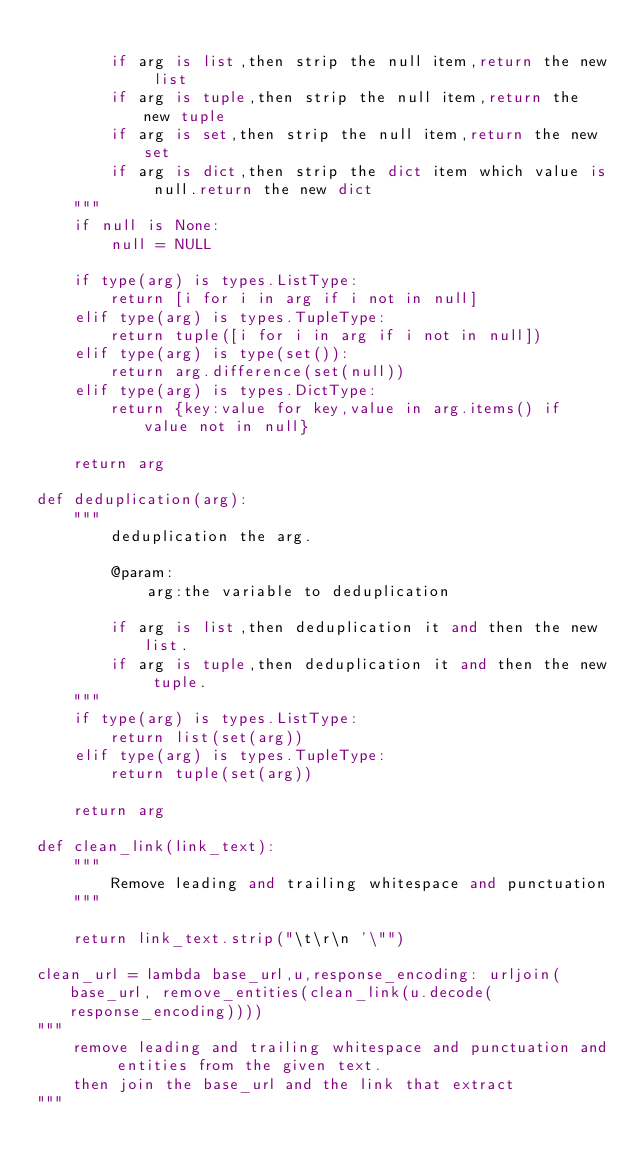<code> <loc_0><loc_0><loc_500><loc_500><_Python_>
        if arg is list,then strip the null item,return the new list
        if arg is tuple,then strip the null item,return the new tuple
        if arg is set,then strip the null item,return the new set
        if arg is dict,then strip the dict item which value is null.return the new dict
    """
    if null is None:
        null = NULL

    if type(arg) is types.ListType:
        return [i for i in arg if i not in null]
    elif type(arg) is types.TupleType:
        return tuple([i for i in arg if i not in null])
    elif type(arg) is type(set()):
        return arg.difference(set(null))
    elif type(arg) is types.DictType:
        return {key:value for key,value in arg.items() if value not in null}

    return arg

def deduplication(arg):
    """
        deduplication the arg.

        @param:
            arg:the variable to deduplication

        if arg is list,then deduplication it and then the new list.
        if arg is tuple,then deduplication it and then the new tuple.
    """
    if type(arg) is types.ListType:
        return list(set(arg))
    elif type(arg) is types.TupleType:
        return tuple(set(arg))

    return arg

def clean_link(link_text):
    """
        Remove leading and trailing whitespace and punctuation
    """

    return link_text.strip("\t\r\n '\"")

clean_url = lambda base_url,u,response_encoding: urljoin(base_url, remove_entities(clean_link(u.decode(response_encoding))))
"""
    remove leading and trailing whitespace and punctuation and entities from the given text.
    then join the base_url and the link that extract
"""
</code> 